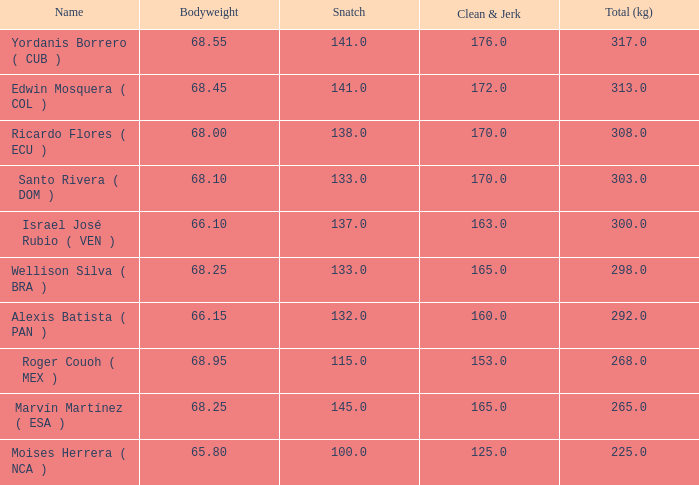For which total (kg) are the clean & jerk and snatch measurements lower than 153 and 100, respectively? None. 